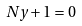<formula> <loc_0><loc_0><loc_500><loc_500>N y + 1 = 0</formula> 